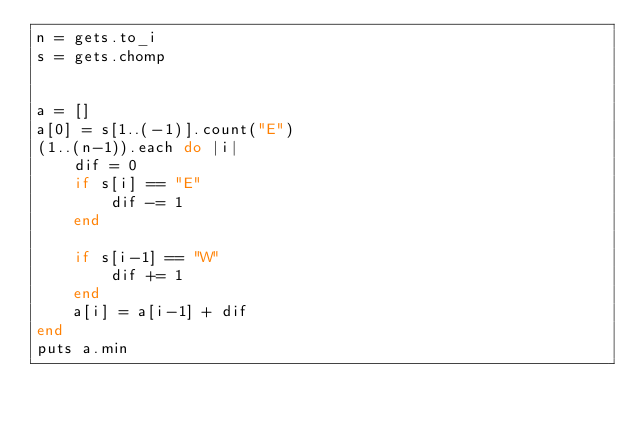<code> <loc_0><loc_0><loc_500><loc_500><_Ruby_>n = gets.to_i
s = gets.chomp
 
 
a = []
a[0] = s[1..(-1)].count("E")
(1..(n-1)).each do |i|
    dif = 0
    if s[i] == "E"
        dif -= 1
    end
    
    if s[i-1] == "W"
        dif += 1
    end
    a[i] = a[i-1] + dif
end
puts a.min</code> 